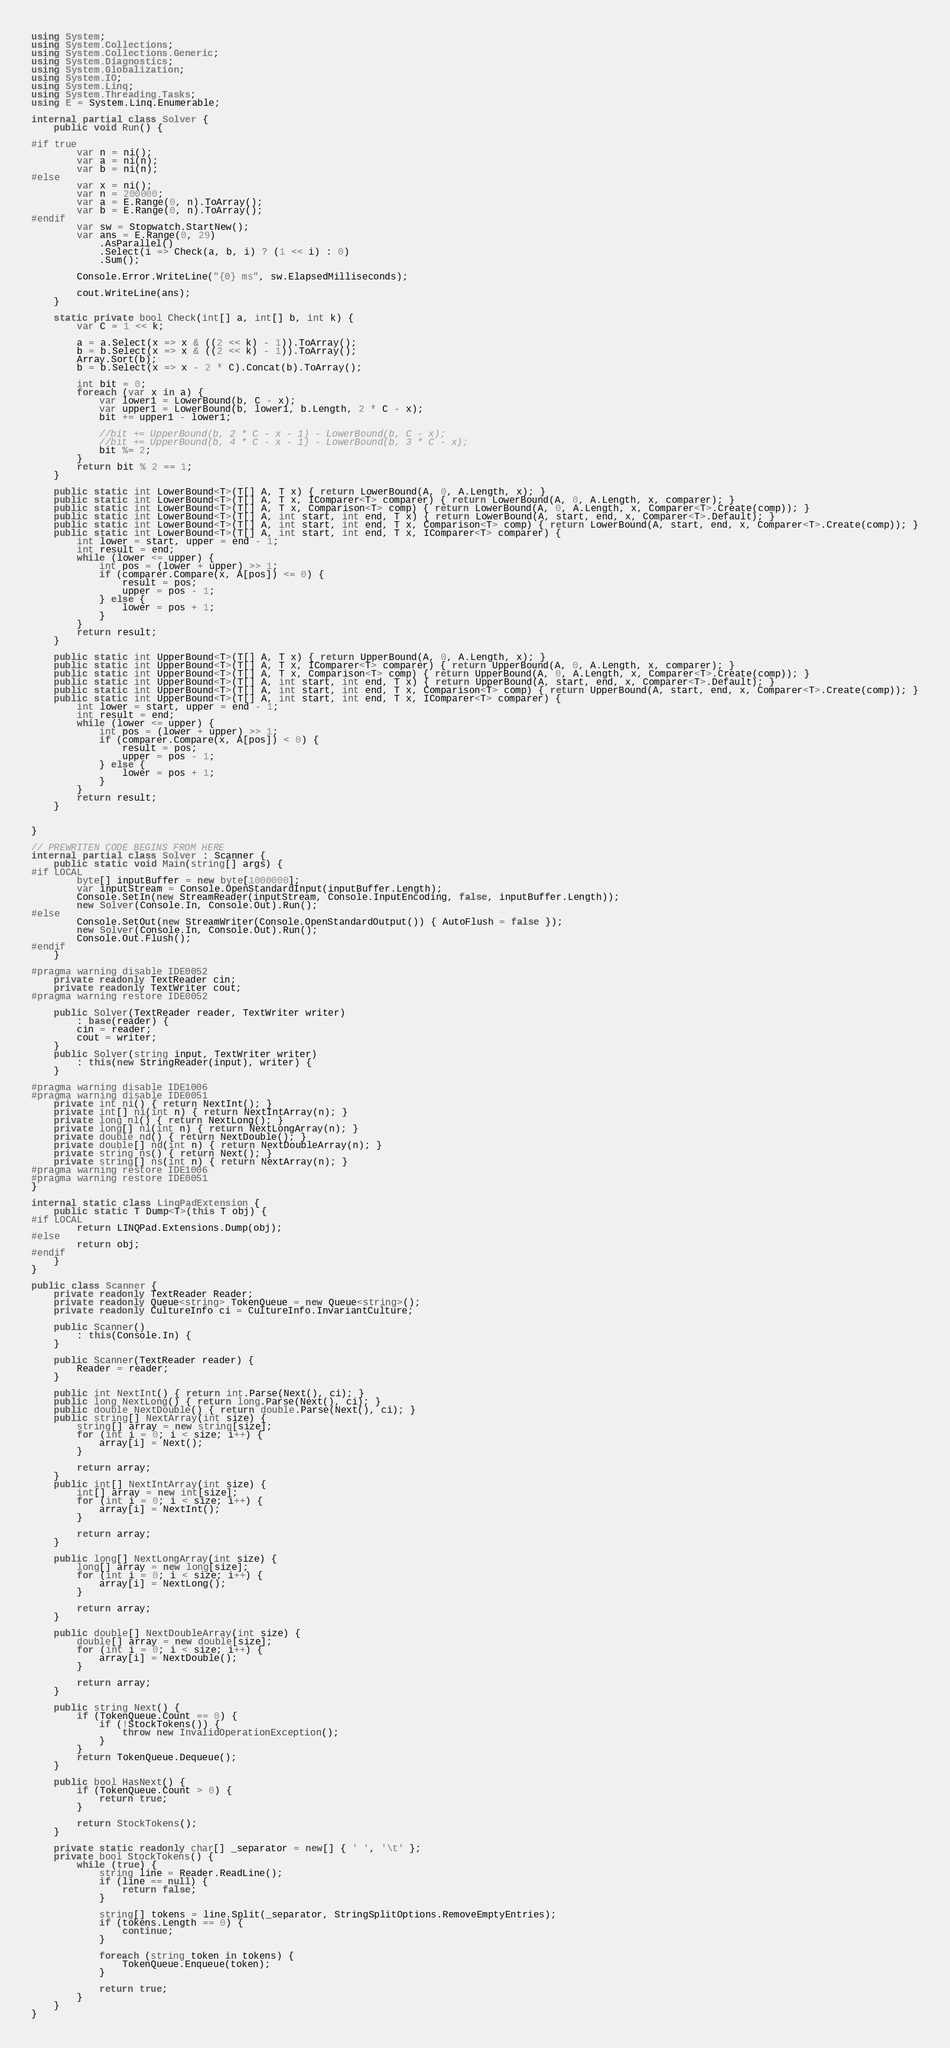<code> <loc_0><loc_0><loc_500><loc_500><_C#_>using System;
using System.Collections;
using System.Collections.Generic;
using System.Diagnostics;
using System.Globalization;
using System.IO;
using System.Linq;
using System.Threading.Tasks;
using E = System.Linq.Enumerable;

internal partial class Solver {
    public void Run() {

#if true
        var n = ni();
        var a = ni(n);
        var b = ni(n);
#else
        var x = ni();
        var n = 200000;
        var a = E.Range(0, n).ToArray();
        var b = E.Range(0, n).ToArray();
#endif
        var sw = Stopwatch.StartNew();
        var ans = E.Range(0, 29)
            .AsParallel()
            .Select(i => Check(a, b, i) ? (1 << i) : 0)
            .Sum();

        Console.Error.WriteLine("{0} ms", sw.ElapsedMilliseconds);

        cout.WriteLine(ans);
    }

    static private bool Check(int[] a, int[] b, int k) {
        var C = 1 << k;

        a = a.Select(x => x & ((2 << k) - 1)).ToArray();
        b = b.Select(x => x & ((2 << k) - 1)).ToArray();
        Array.Sort(b);
        b = b.Select(x => x - 2 * C).Concat(b).ToArray();

        int bit = 0;
        foreach (var x in a) {
            var lower1 = LowerBound(b, C - x);
            var upper1 = LowerBound(b, lower1, b.Length, 2 * C - x);
            bit += upper1 - lower1;

            //bit += UpperBound(b, 2 * C - x - 1) - LowerBound(b, C - x);
            //bit += UpperBound(b, 4 * C - x - 1) - LowerBound(b, 3 * C - x);
            bit %= 2;
        }
        return bit % 2 == 1;
    }

    public static int LowerBound<T>(T[] A, T x) { return LowerBound(A, 0, A.Length, x); }
    public static int LowerBound<T>(T[] A, T x, IComparer<T> comparer) { return LowerBound(A, 0, A.Length, x, comparer); }
    public static int LowerBound<T>(T[] A, T x, Comparison<T> comp) { return LowerBound(A, 0, A.Length, x, Comparer<T>.Create(comp)); }
    public static int LowerBound<T>(T[] A, int start, int end, T x) { return LowerBound(A, start, end, x, Comparer<T>.Default); }
    public static int LowerBound<T>(T[] A, int start, int end, T x, Comparison<T> comp) { return LowerBound(A, start, end, x, Comparer<T>.Create(comp)); }
    public static int LowerBound<T>(T[] A, int start, int end, T x, IComparer<T> comparer) {
        int lower = start, upper = end - 1;
        int result = end;
        while (lower <= upper) {
            int pos = (lower + upper) >> 1;
            if (comparer.Compare(x, A[pos]) <= 0) {
                result = pos;
                upper = pos - 1;
            } else {
                lower = pos + 1;
            }
        }
        return result;
    }

    public static int UpperBound<T>(T[] A, T x) { return UpperBound(A, 0, A.Length, x); }
    public static int UpperBound<T>(T[] A, T x, IComparer<T> comparer) { return UpperBound(A, 0, A.Length, x, comparer); }
    public static int UpperBound<T>(T[] A, T x, Comparison<T> comp) { return UpperBound(A, 0, A.Length, x, Comparer<T>.Create(comp)); }
    public static int UpperBound<T>(T[] A, int start, int end, T x) { return UpperBound(A, start, end, x, Comparer<T>.Default); }
    public static int UpperBound<T>(T[] A, int start, int end, T x, Comparison<T> comp) { return UpperBound(A, start, end, x, Comparer<T>.Create(comp)); }
    public static int UpperBound<T>(T[] A, int start, int end, T x, IComparer<T> comparer) {
        int lower = start, upper = end - 1;
        int result = end;
        while (lower <= upper) {
            int pos = (lower + upper) >> 1;
            if (comparer.Compare(x, A[pos]) < 0) {
                result = pos;
                upper = pos - 1;
            } else {
                lower = pos + 1;
            }
        }
        return result;
    }


}

// PREWRITEN CODE BEGINS FROM HERE
internal partial class Solver : Scanner {
    public static void Main(string[] args) {
#if LOCAL
        byte[] inputBuffer = new byte[1000000];
        var inputStream = Console.OpenStandardInput(inputBuffer.Length);
        Console.SetIn(new StreamReader(inputStream, Console.InputEncoding, false, inputBuffer.Length));
        new Solver(Console.In, Console.Out).Run();
#else
        Console.SetOut(new StreamWriter(Console.OpenStandardOutput()) { AutoFlush = false });
        new Solver(Console.In, Console.Out).Run();
        Console.Out.Flush();
#endif
    }

#pragma warning disable IDE0052
    private readonly TextReader cin;
    private readonly TextWriter cout;
#pragma warning restore IDE0052

    public Solver(TextReader reader, TextWriter writer)
        : base(reader) {
        cin = reader;
        cout = writer;
    }
    public Solver(string input, TextWriter writer)
        : this(new StringReader(input), writer) {
    }

#pragma warning disable IDE1006
#pragma warning disable IDE0051
    private int ni() { return NextInt(); }
    private int[] ni(int n) { return NextIntArray(n); }
    private long nl() { return NextLong(); }
    private long[] nl(int n) { return NextLongArray(n); }
    private double nd() { return NextDouble(); }
    private double[] nd(int n) { return NextDoubleArray(n); }
    private string ns() { return Next(); }
    private string[] ns(int n) { return NextArray(n); }
#pragma warning restore IDE1006
#pragma warning restore IDE0051
}

internal static class LinqPadExtension {
    public static T Dump<T>(this T obj) {
#if LOCAL
        return LINQPad.Extensions.Dump(obj);
#else
        return obj;
#endif
    }
}

public class Scanner {
    private readonly TextReader Reader;
    private readonly Queue<string> TokenQueue = new Queue<string>();
    private readonly CultureInfo ci = CultureInfo.InvariantCulture;

    public Scanner()
        : this(Console.In) {
    }

    public Scanner(TextReader reader) {
        Reader = reader;
    }

    public int NextInt() { return int.Parse(Next(), ci); }
    public long NextLong() { return long.Parse(Next(), ci); }
    public double NextDouble() { return double.Parse(Next(), ci); }
    public string[] NextArray(int size) {
        string[] array = new string[size];
        for (int i = 0; i < size; i++) {
            array[i] = Next();
        }

        return array;
    }
    public int[] NextIntArray(int size) {
        int[] array = new int[size];
        for (int i = 0; i < size; i++) {
            array[i] = NextInt();
        }

        return array;
    }

    public long[] NextLongArray(int size) {
        long[] array = new long[size];
        for (int i = 0; i < size; i++) {
            array[i] = NextLong();
        }

        return array;
    }

    public double[] NextDoubleArray(int size) {
        double[] array = new double[size];
        for (int i = 0; i < size; i++) {
            array[i] = NextDouble();
        }

        return array;
    }

    public string Next() {
        if (TokenQueue.Count == 0) {
            if (!StockTokens()) {
                throw new InvalidOperationException();
            }
        }
        return TokenQueue.Dequeue();
    }

    public bool HasNext() {
        if (TokenQueue.Count > 0) {
            return true;
        }

        return StockTokens();
    }

    private static readonly char[] _separator = new[] { ' ', '\t' };
    private bool StockTokens() {
        while (true) {
            string line = Reader.ReadLine();
            if (line == null) {
                return false;
            }

            string[] tokens = line.Split(_separator, StringSplitOptions.RemoveEmptyEntries);
            if (tokens.Length == 0) {
                continue;
            }

            foreach (string token in tokens) {
                TokenQueue.Enqueue(token);
            }

            return true;
        }
    }
}
</code> 